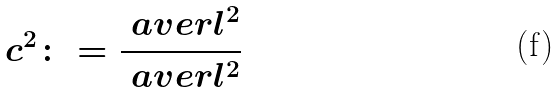Convert formula to latex. <formula><loc_0><loc_0><loc_500><loc_500>c ^ { 2 } \colon = \frac { \ a v e r { l } ^ { 2 } } { \ a v e r { l ^ { 2 } } }</formula> 